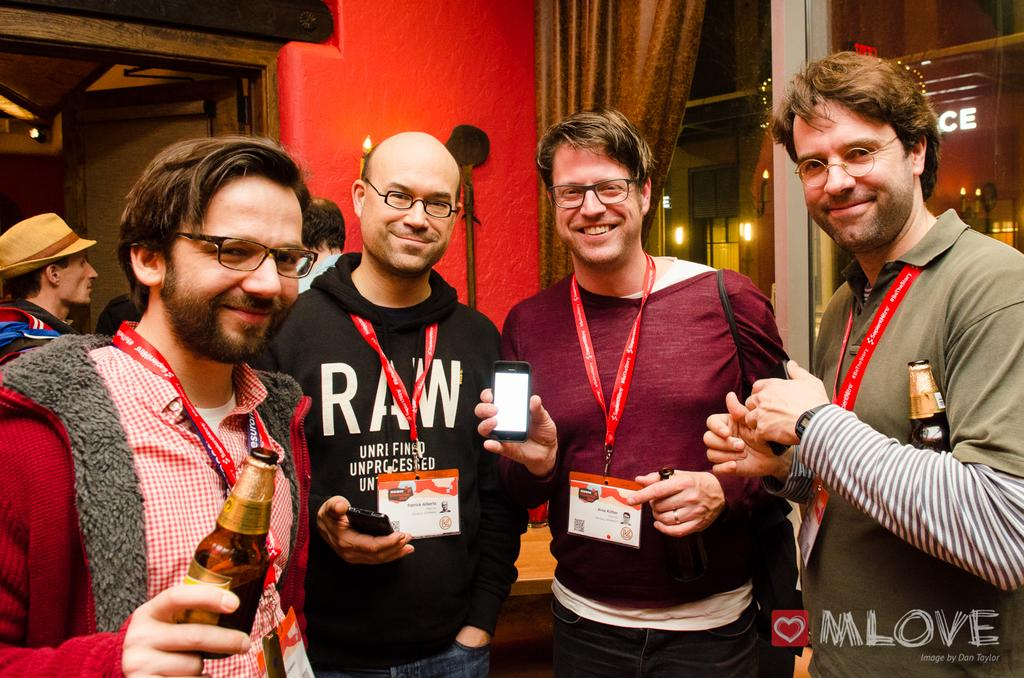How many people are present in the image? There are four persons standing in the image. What are two of the persons holding? Two of the persons are holding a bottle. What is the person wearing a red t-shirt holding? The person wearing a red t-shirt is holding a mobile. What can be seen in the background of the image? There is a curtain in the image, and the wall is in red color. Can you describe the lighting in the image? There are lights visible in the distance. What invention is the person wearing a red t-shirt demonstrating in the image? There is no invention being demonstrated in the image; the person wearing a red t-shirt is simply holding a mobile. How many brothers are present in the image? The concept of "brothers" is not mentioned in the image, so it cannot be determined from the image. 